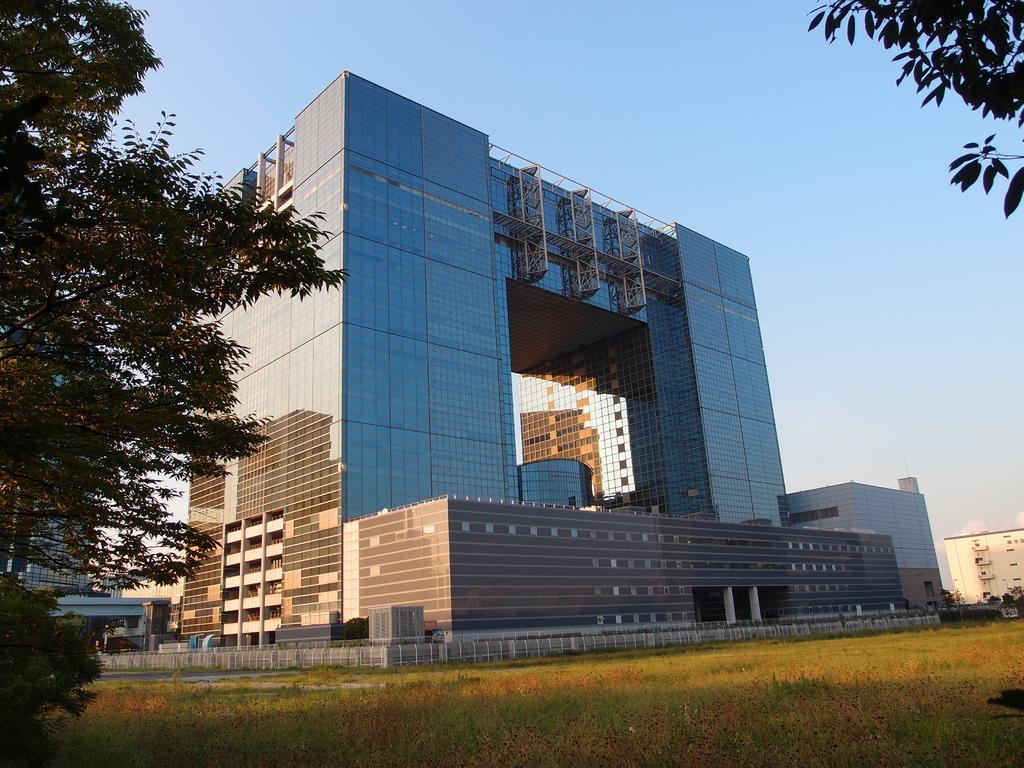How would you summarize this image in a sentence or two? In this image I can see the grass. On the left side I can see a tree. In the background, I can see the buildings and the sky. 